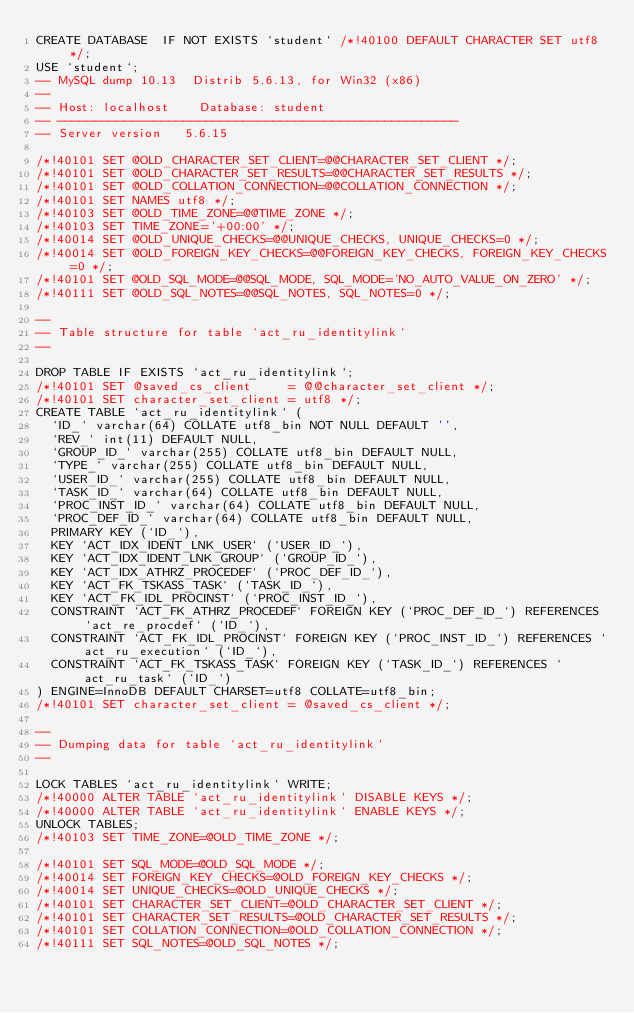<code> <loc_0><loc_0><loc_500><loc_500><_SQL_>CREATE DATABASE  IF NOT EXISTS `student` /*!40100 DEFAULT CHARACTER SET utf8 */;
USE `student`;
-- MySQL dump 10.13  Distrib 5.6.13, for Win32 (x86)
--
-- Host: localhost    Database: student
-- ------------------------------------------------------
-- Server version	5.6.15

/*!40101 SET @OLD_CHARACTER_SET_CLIENT=@@CHARACTER_SET_CLIENT */;
/*!40101 SET @OLD_CHARACTER_SET_RESULTS=@@CHARACTER_SET_RESULTS */;
/*!40101 SET @OLD_COLLATION_CONNECTION=@@COLLATION_CONNECTION */;
/*!40101 SET NAMES utf8 */;
/*!40103 SET @OLD_TIME_ZONE=@@TIME_ZONE */;
/*!40103 SET TIME_ZONE='+00:00' */;
/*!40014 SET @OLD_UNIQUE_CHECKS=@@UNIQUE_CHECKS, UNIQUE_CHECKS=0 */;
/*!40014 SET @OLD_FOREIGN_KEY_CHECKS=@@FOREIGN_KEY_CHECKS, FOREIGN_KEY_CHECKS=0 */;
/*!40101 SET @OLD_SQL_MODE=@@SQL_MODE, SQL_MODE='NO_AUTO_VALUE_ON_ZERO' */;
/*!40111 SET @OLD_SQL_NOTES=@@SQL_NOTES, SQL_NOTES=0 */;

--
-- Table structure for table `act_ru_identitylink`
--

DROP TABLE IF EXISTS `act_ru_identitylink`;
/*!40101 SET @saved_cs_client     = @@character_set_client */;
/*!40101 SET character_set_client = utf8 */;
CREATE TABLE `act_ru_identitylink` (
  `ID_` varchar(64) COLLATE utf8_bin NOT NULL DEFAULT '',
  `REV_` int(11) DEFAULT NULL,
  `GROUP_ID_` varchar(255) COLLATE utf8_bin DEFAULT NULL,
  `TYPE_` varchar(255) COLLATE utf8_bin DEFAULT NULL,
  `USER_ID_` varchar(255) COLLATE utf8_bin DEFAULT NULL,
  `TASK_ID_` varchar(64) COLLATE utf8_bin DEFAULT NULL,
  `PROC_INST_ID_` varchar(64) COLLATE utf8_bin DEFAULT NULL,
  `PROC_DEF_ID_` varchar(64) COLLATE utf8_bin DEFAULT NULL,
  PRIMARY KEY (`ID_`),
  KEY `ACT_IDX_IDENT_LNK_USER` (`USER_ID_`),
  KEY `ACT_IDX_IDENT_LNK_GROUP` (`GROUP_ID_`),
  KEY `ACT_IDX_ATHRZ_PROCEDEF` (`PROC_DEF_ID_`),
  KEY `ACT_FK_TSKASS_TASK` (`TASK_ID_`),
  KEY `ACT_FK_IDL_PROCINST` (`PROC_INST_ID_`),
  CONSTRAINT `ACT_FK_ATHRZ_PROCEDEF` FOREIGN KEY (`PROC_DEF_ID_`) REFERENCES `act_re_procdef` (`ID_`),
  CONSTRAINT `ACT_FK_IDL_PROCINST` FOREIGN KEY (`PROC_INST_ID_`) REFERENCES `act_ru_execution` (`ID_`),
  CONSTRAINT `ACT_FK_TSKASS_TASK` FOREIGN KEY (`TASK_ID_`) REFERENCES `act_ru_task` (`ID_`)
) ENGINE=InnoDB DEFAULT CHARSET=utf8 COLLATE=utf8_bin;
/*!40101 SET character_set_client = @saved_cs_client */;

--
-- Dumping data for table `act_ru_identitylink`
--

LOCK TABLES `act_ru_identitylink` WRITE;
/*!40000 ALTER TABLE `act_ru_identitylink` DISABLE KEYS */;
/*!40000 ALTER TABLE `act_ru_identitylink` ENABLE KEYS */;
UNLOCK TABLES;
/*!40103 SET TIME_ZONE=@OLD_TIME_ZONE */;

/*!40101 SET SQL_MODE=@OLD_SQL_MODE */;
/*!40014 SET FOREIGN_KEY_CHECKS=@OLD_FOREIGN_KEY_CHECKS */;
/*!40014 SET UNIQUE_CHECKS=@OLD_UNIQUE_CHECKS */;
/*!40101 SET CHARACTER_SET_CLIENT=@OLD_CHARACTER_SET_CLIENT */;
/*!40101 SET CHARACTER_SET_RESULTS=@OLD_CHARACTER_SET_RESULTS */;
/*!40101 SET COLLATION_CONNECTION=@OLD_COLLATION_CONNECTION */;
/*!40111 SET SQL_NOTES=@OLD_SQL_NOTES */;
</code> 